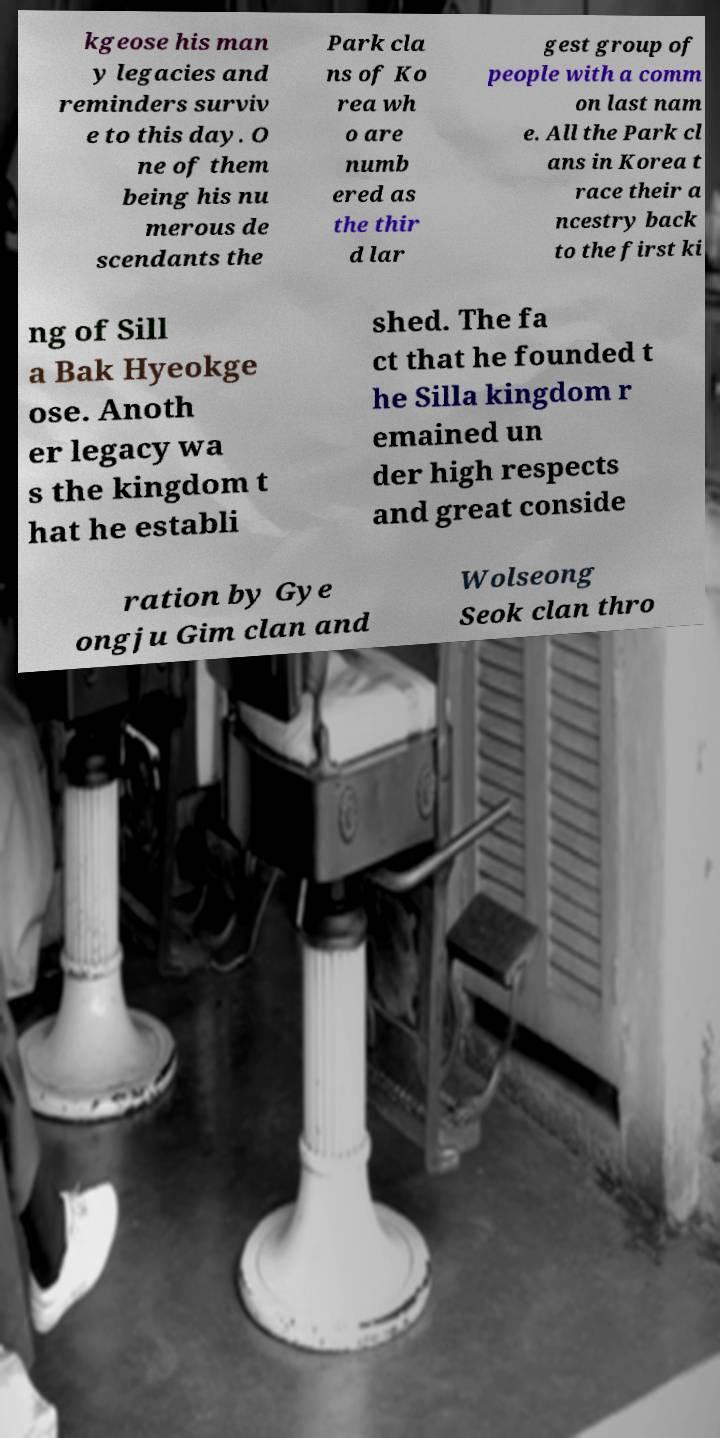Can you read and provide the text displayed in the image?This photo seems to have some interesting text. Can you extract and type it out for me? kgeose his man y legacies and reminders surviv e to this day. O ne of them being his nu merous de scendants the Park cla ns of Ko rea wh o are numb ered as the thir d lar gest group of people with a comm on last nam e. All the Park cl ans in Korea t race their a ncestry back to the first ki ng of Sill a Bak Hyeokge ose. Anoth er legacy wa s the kingdom t hat he establi shed. The fa ct that he founded t he Silla kingdom r emained un der high respects and great conside ration by Gye ongju Gim clan and Wolseong Seok clan thro 